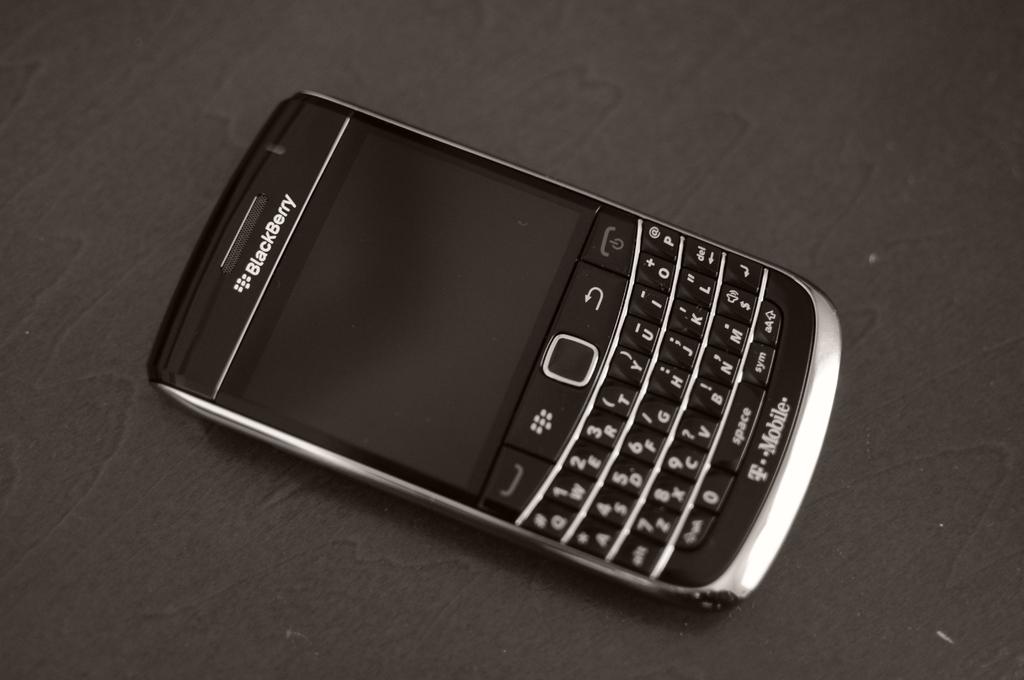What brand of phone is this?
Ensure brevity in your answer.  Blackberry. What service is this phone used on?
Your answer should be compact. T mobile. 